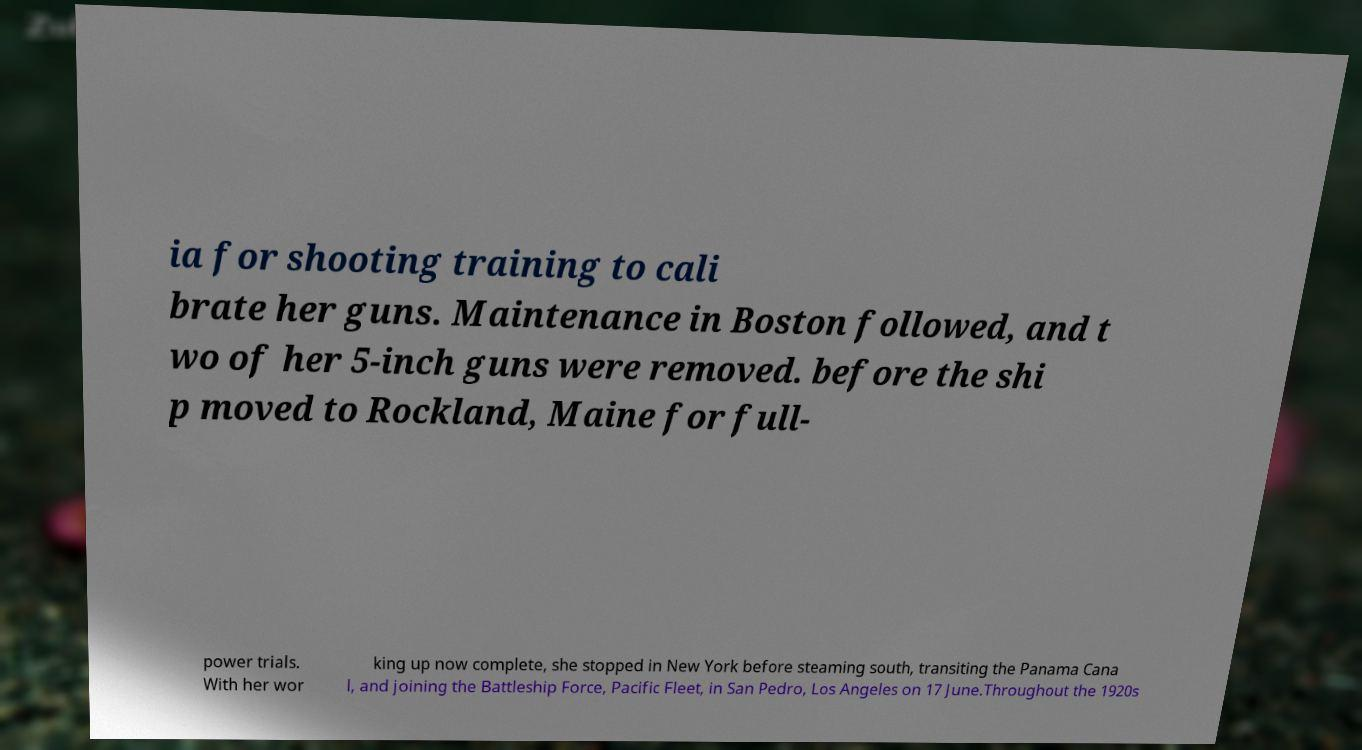I need the written content from this picture converted into text. Can you do that? ia for shooting training to cali brate her guns. Maintenance in Boston followed, and t wo of her 5-inch guns were removed. before the shi p moved to Rockland, Maine for full- power trials. With her wor king up now complete, she stopped in New York before steaming south, transiting the Panama Cana l, and joining the Battleship Force, Pacific Fleet, in San Pedro, Los Angeles on 17 June.Throughout the 1920s 